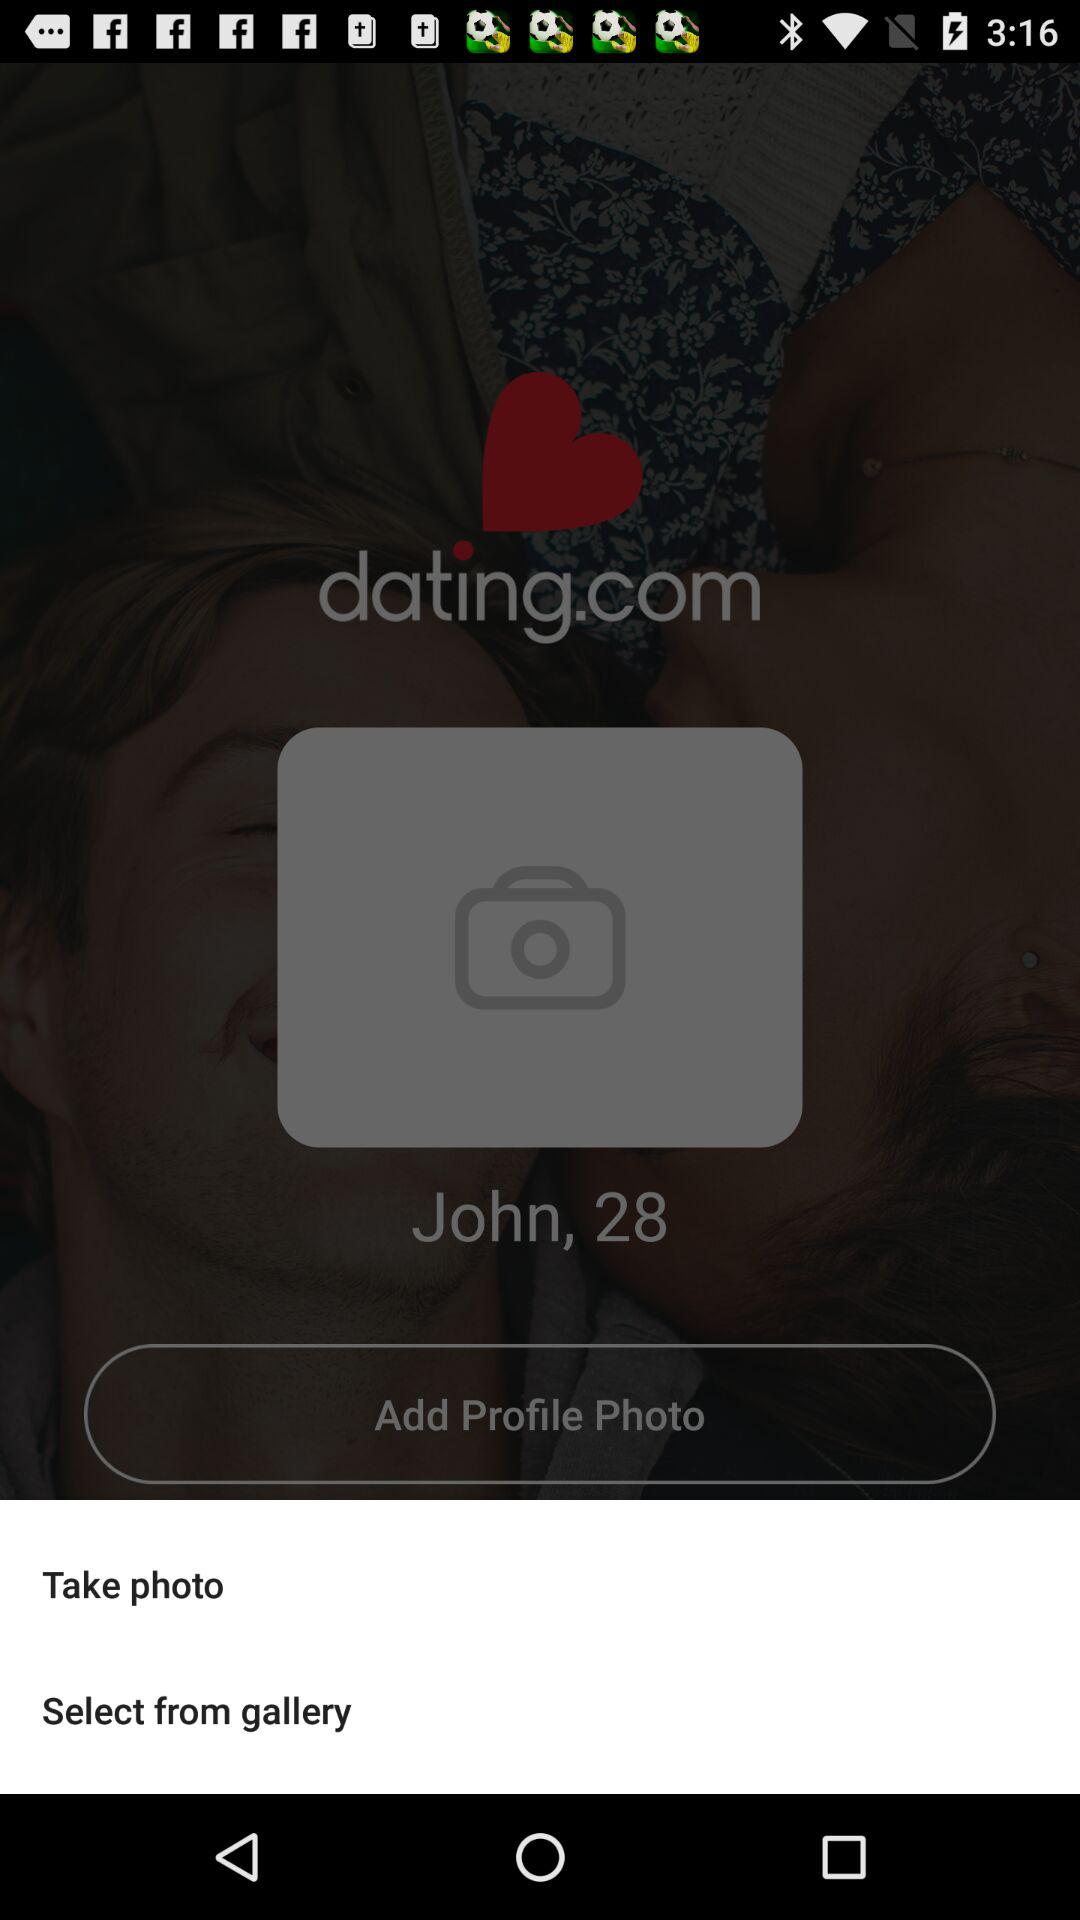What is the age of the user? The age of the user is 28. 